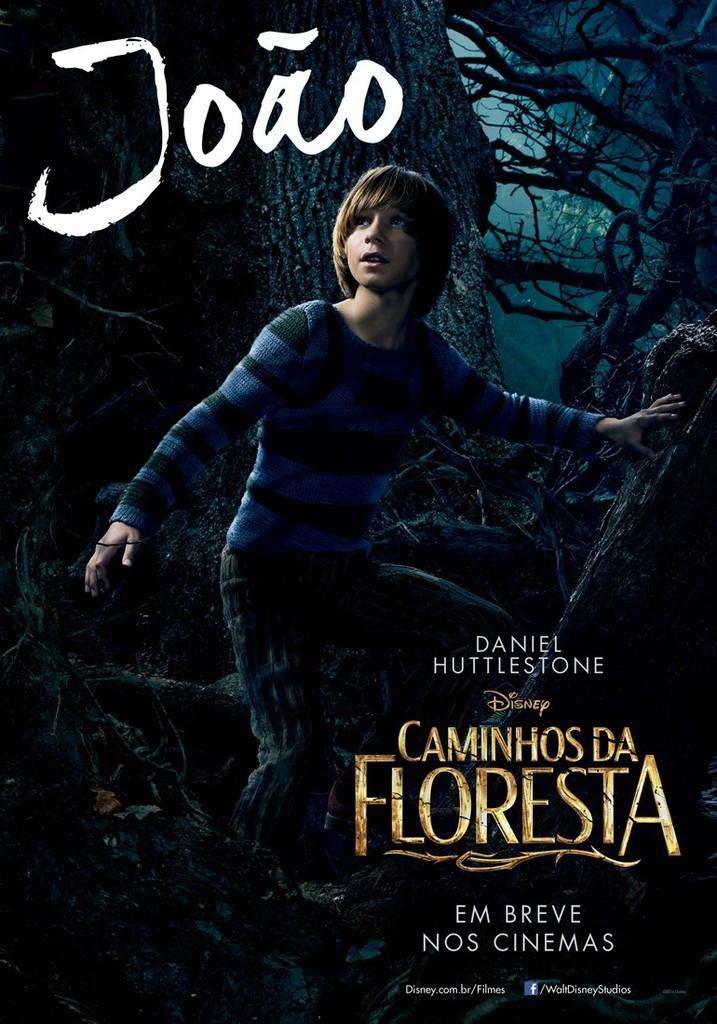What is the title?
Give a very brief answer. Caminhos da floresta. 